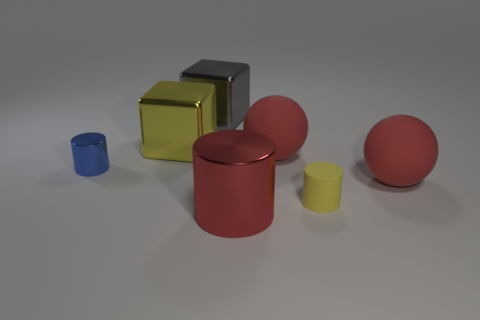Is the size of the gray metal cube the same as the blue metal object?
Give a very brief answer. No. How many things are big gray cubes or objects that are to the left of the tiny yellow matte object?
Keep it short and to the point. 5. There is a sphere that is in front of the big ball behind the tiny metallic cylinder; what color is it?
Provide a short and direct response. Red. There is a small cylinder behind the tiny yellow rubber cylinder; is it the same color as the tiny rubber thing?
Offer a very short reply. No. There is a large sphere that is in front of the tiny shiny thing; what material is it?
Ensure brevity in your answer.  Rubber. The yellow metallic object is what size?
Give a very brief answer. Large. Is the material of the tiny object that is left of the large gray shiny cube the same as the yellow cylinder?
Your answer should be compact. No. How many red shiny things are there?
Offer a very short reply. 1. What number of things are cylinders or big cylinders?
Your response must be concise. 3. How many big rubber spheres are to the right of the red rubber thing that is in front of the red sphere that is behind the tiny blue metal thing?
Keep it short and to the point. 0. 